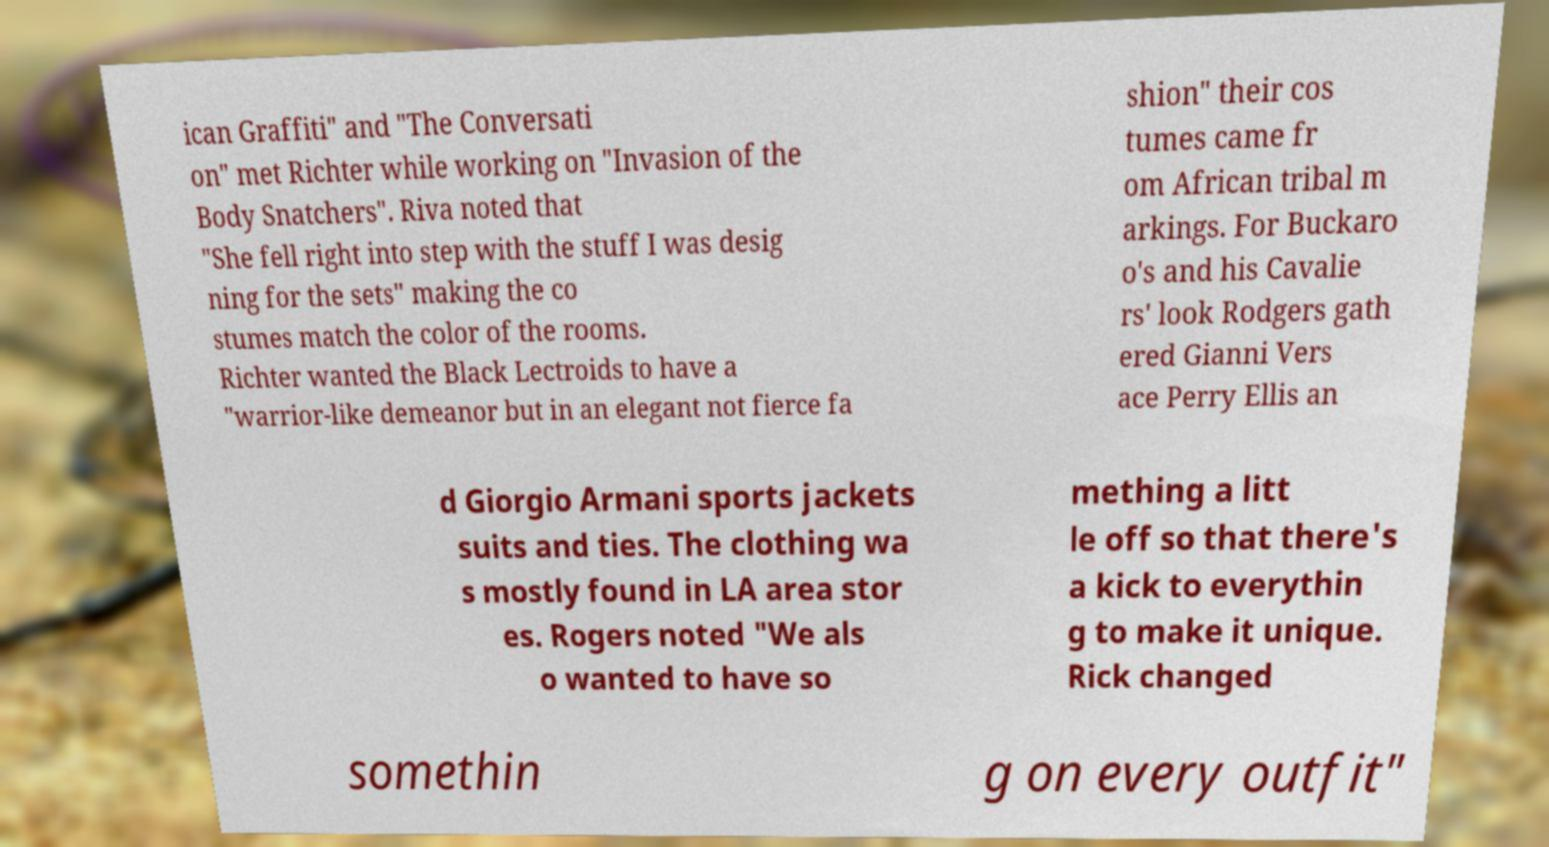Please read and relay the text visible in this image. What does it say? ican Graffiti" and "The Conversati on" met Richter while working on "Invasion of the Body Snatchers". Riva noted that "She fell right into step with the stuff I was desig ning for the sets" making the co stumes match the color of the rooms. Richter wanted the Black Lectroids to have a "warrior-like demeanor but in an elegant not fierce fa shion" their cos tumes came fr om African tribal m arkings. For Buckaro o's and his Cavalie rs' look Rodgers gath ered Gianni Vers ace Perry Ellis an d Giorgio Armani sports jackets suits and ties. The clothing wa s mostly found in LA area stor es. Rogers noted "We als o wanted to have so mething a litt le off so that there's a kick to everythin g to make it unique. Rick changed somethin g on every outfit" 